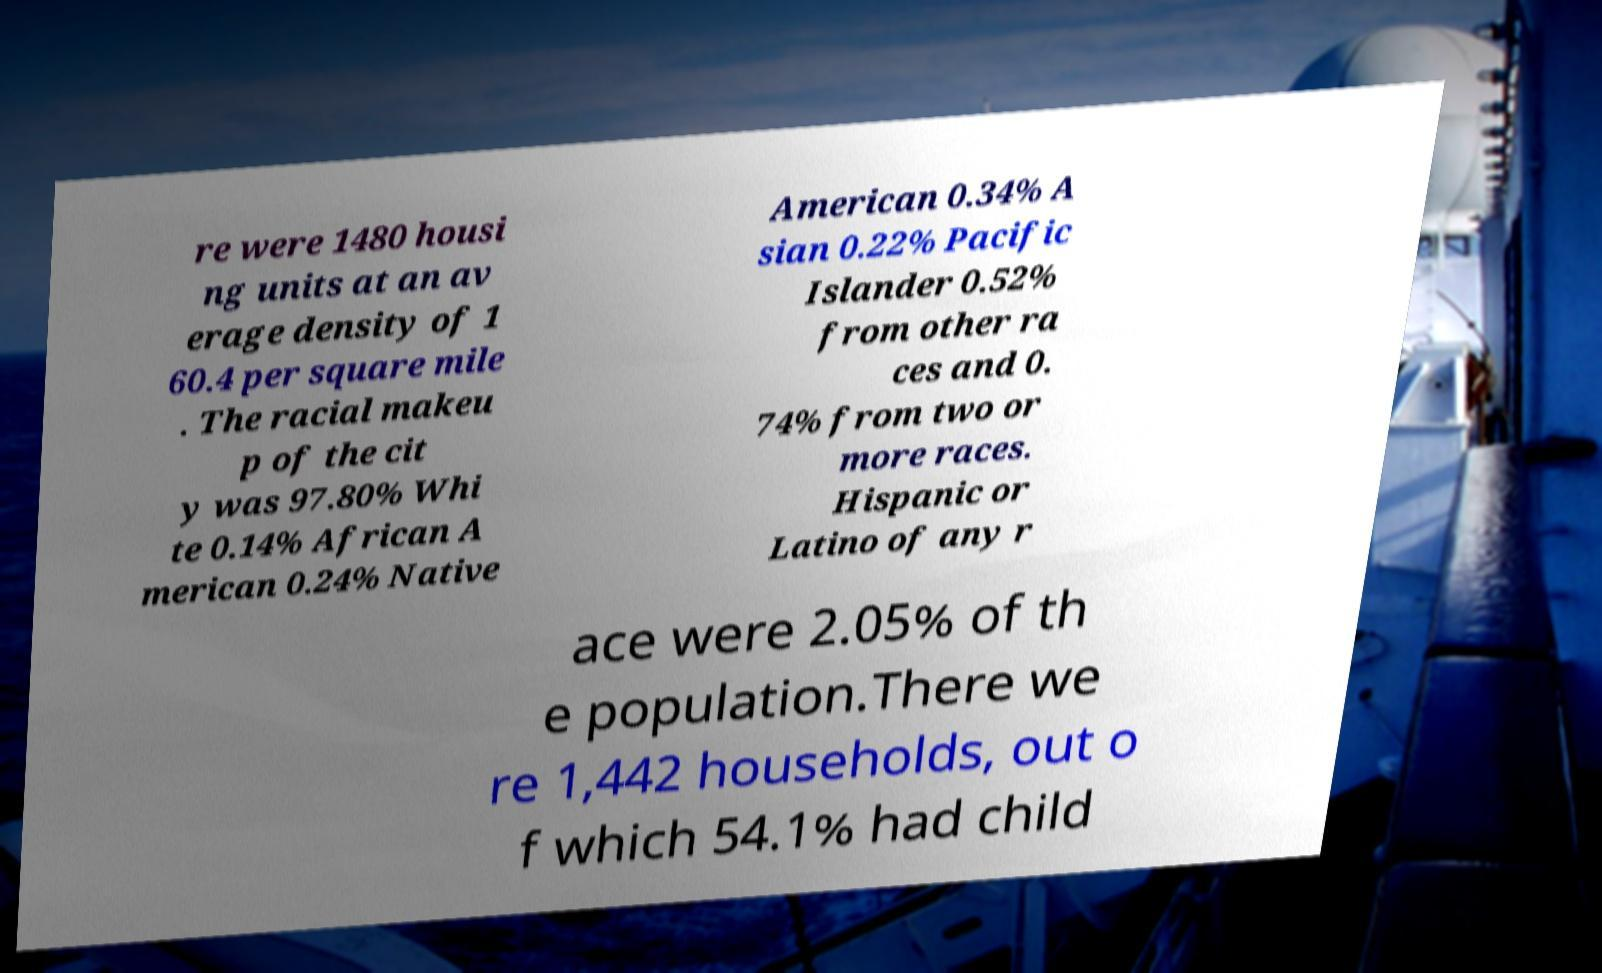Please read and relay the text visible in this image. What does it say? re were 1480 housi ng units at an av erage density of 1 60.4 per square mile . The racial makeu p of the cit y was 97.80% Whi te 0.14% African A merican 0.24% Native American 0.34% A sian 0.22% Pacific Islander 0.52% from other ra ces and 0. 74% from two or more races. Hispanic or Latino of any r ace were 2.05% of th e population.There we re 1,442 households, out o f which 54.1% had child 